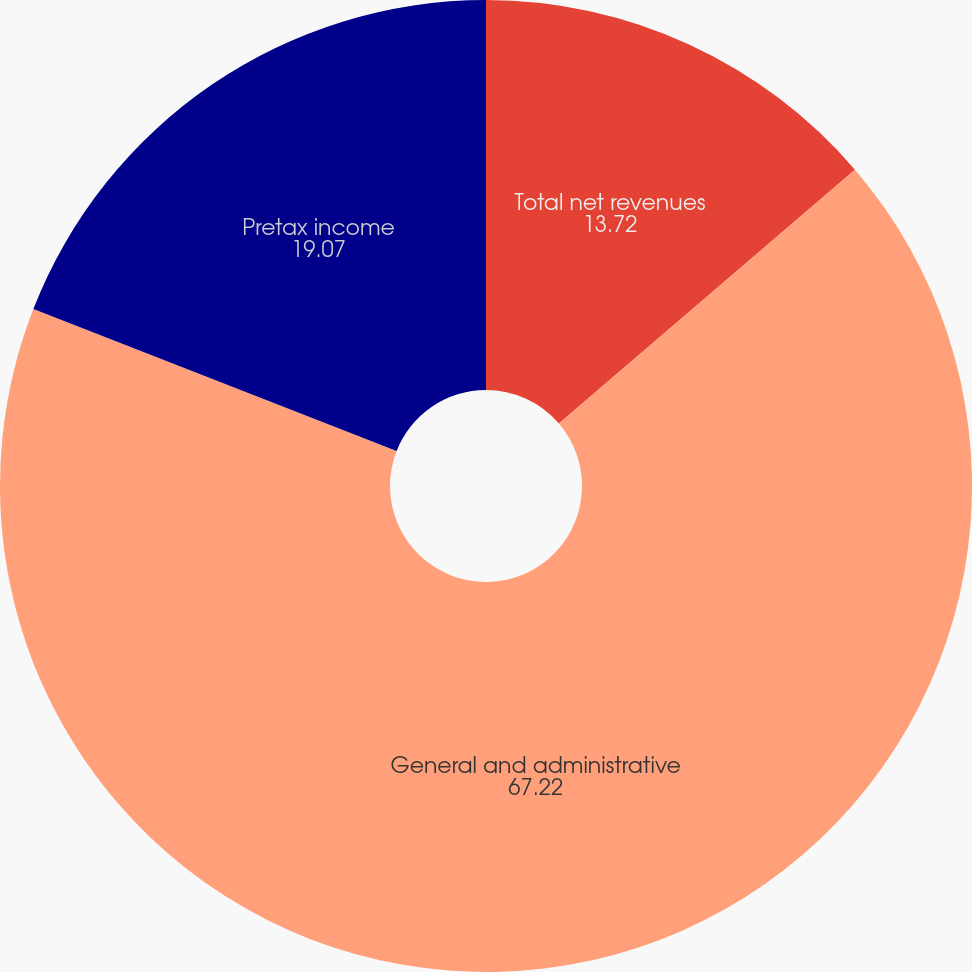Convert chart. <chart><loc_0><loc_0><loc_500><loc_500><pie_chart><fcel>Total net revenues<fcel>General and administrative<fcel>Pretax income<nl><fcel>13.72%<fcel>67.22%<fcel>19.07%<nl></chart> 